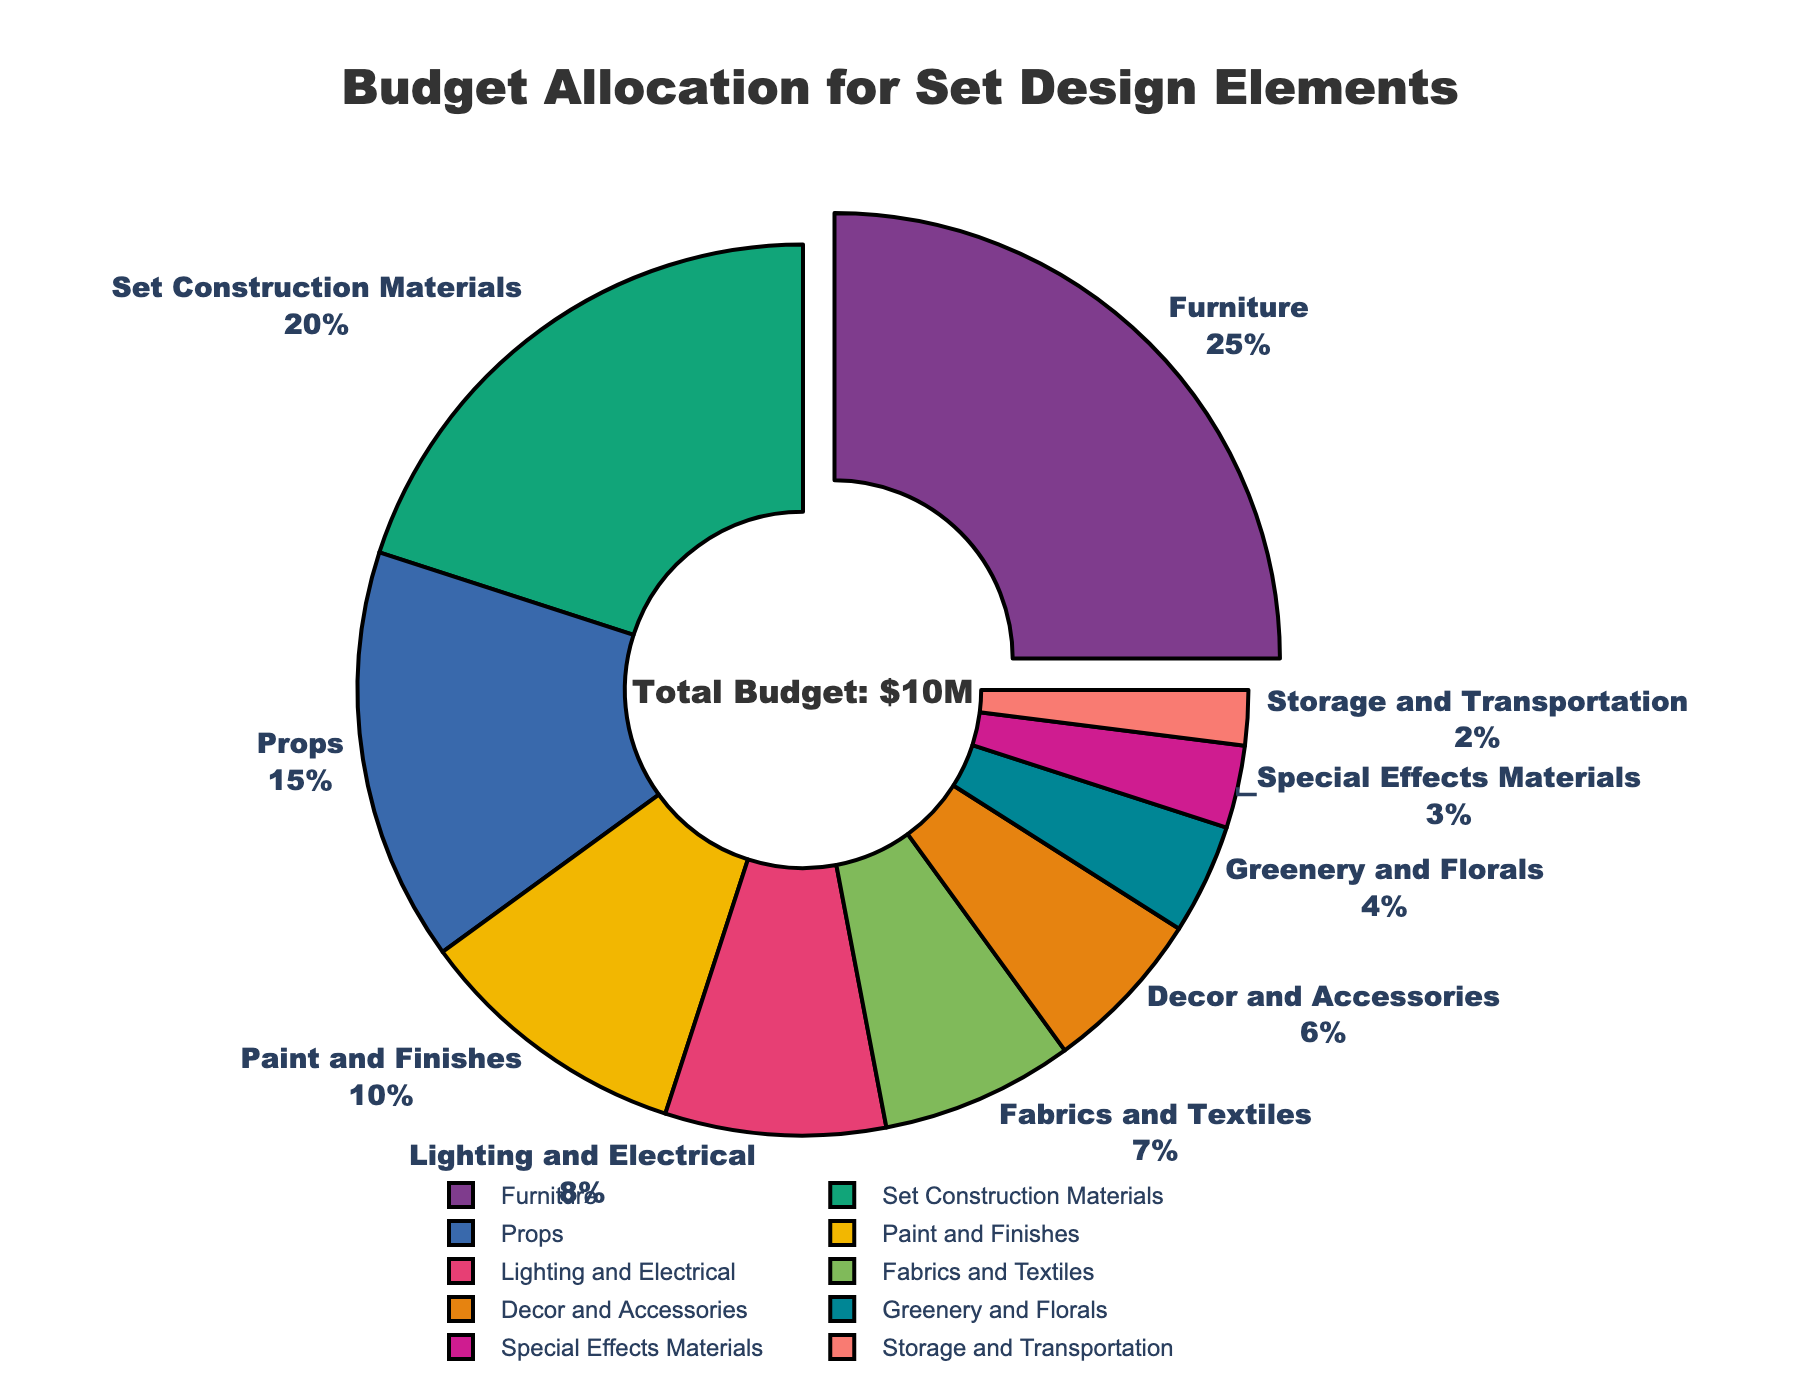What percentage of the budget is allocated to lighting and electrical? Locate the section labeled "Lighting and Electrical" on the pie chart, and refer to the label that indicates the percentage allocated to it.
Answer: 8% Which category receives the largest portion of the budget? Identify the section of the pie chart that has been slightly pulled out to indicate it’s the largest. Look at the label on this segment to find the category name.
Answer: Furniture What is the total percentage of the budget allocated for props and special effects materials combined? Locate the segments labeled "Props" and "Special Effects Materials" and add the two percentages. Props: 15%, Special Effects Materials: 3%, so 15% + 3% = 18%.
Answer: 18% How does the budget for set construction materials compare to that for fabrics and textiles? Locate the segments for "Set Construction Materials" and "Fabrics and Textiles" on the pie chart. Compare their percentages: Set Construction Materials is 20% and Fabrics and Textiles is 7%. Thus, Set Construction Materials is significantly higher than Fabrics and Textiles.
Answer: Set Construction Materials is higher Which category has the lowest percentage of budget allocation? Identify the smallest segment on the pie chart and refer to its label for the category name.
Answer: Storage and Transportation What's the combined budget percentage allocated to decor and accessories, and greenery and florals? Locate the segments labeled "Decor and Accessories" and "Greenery and Florals." Then, add their percentages together. Decor and Accessories: 6%, Greenery and Florals: 4%, so 6% + 4% = 10%.
Answer: 10% Compare the budget allocation for furniture and paint and finishes. Which one has more, and by how much? Locate the segments for "Furniture" and "Paint and Finishes." Furniture is 25% and Paint and Finishes is 10%. Subtract the smaller percentage from the larger one: 25% - 10% = 15%. So, Furniture has 15% more allocation.
Answer: Furniture by 15% If the total budget is $10M, how much money is allocated to props? Given the total budget is $10M, and the percentage allocated to props is 15%, calculate the amount by multiplying the total budget by the percentage: 10M * 0.15 = $1.5M.
Answer: $1.5M 